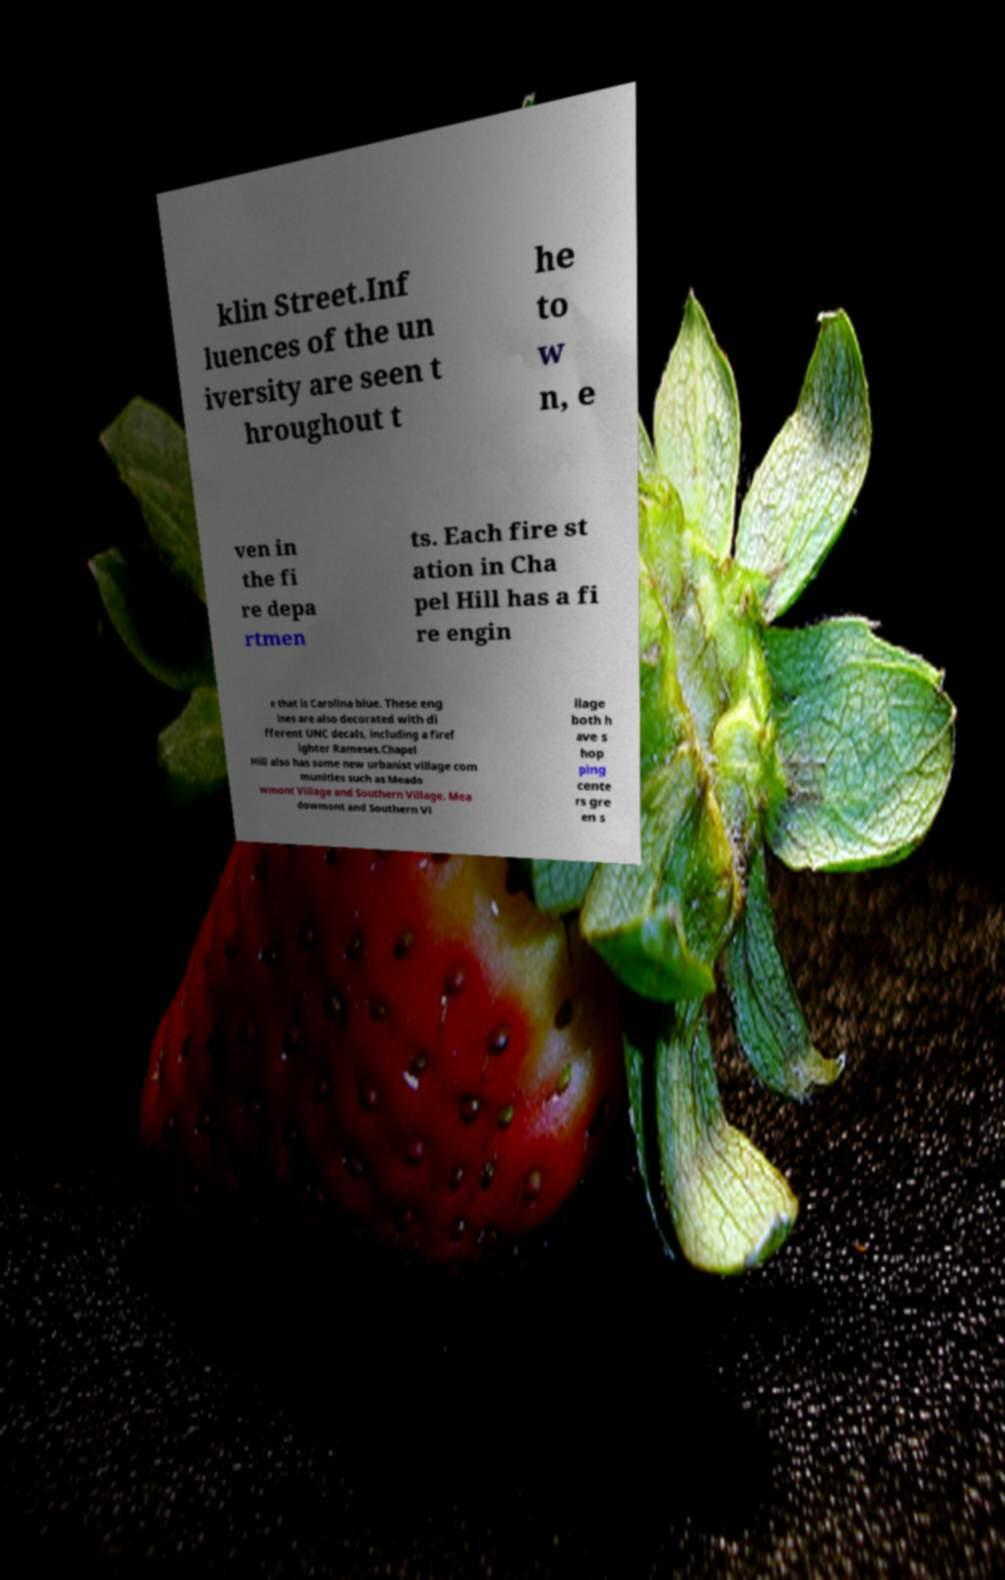Can you accurately transcribe the text from the provided image for me? klin Street.Inf luences of the un iversity are seen t hroughout t he to w n, e ven in the fi re depa rtmen ts. Each fire st ation in Cha pel Hill has a fi re engin e that is Carolina blue. These eng ines are also decorated with di fferent UNC decals, including a firef ighter Rameses.Chapel Hill also has some new urbanist village com munities such as Meado wmont Village and Southern Village. Mea dowmont and Southern Vi llage both h ave s hop ping cente rs gre en s 